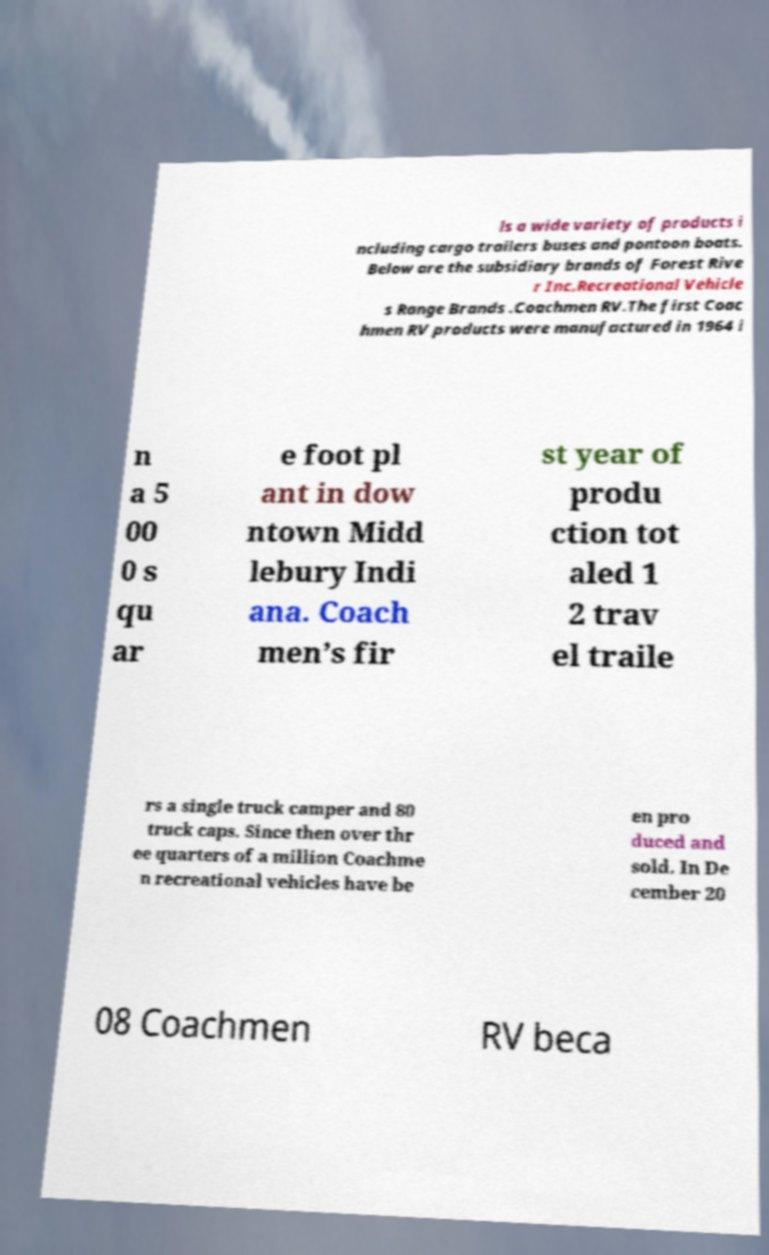Could you assist in decoding the text presented in this image and type it out clearly? ls a wide variety of products i ncluding cargo trailers buses and pontoon boats. Below are the subsidiary brands of Forest Rive r Inc.Recreational Vehicle s Range Brands .Coachmen RV.The first Coac hmen RV products were manufactured in 1964 i n a 5 00 0 s qu ar e foot pl ant in dow ntown Midd lebury Indi ana. Coach men’s fir st year of produ ction tot aled 1 2 trav el traile rs a single truck camper and 80 truck caps. Since then over thr ee quarters of a million Coachme n recreational vehicles have be en pro duced and sold. In De cember 20 08 Coachmen RV beca 